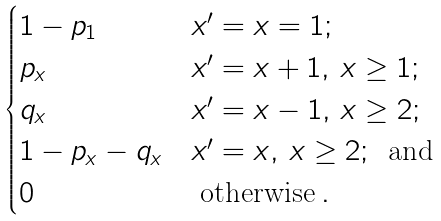Convert formula to latex. <formula><loc_0><loc_0><loc_500><loc_500>\begin{cases} 1 - p _ { 1 } & x ^ { \prime } = x = 1 ; \\ p _ { x } & x ^ { \prime } = x + 1 , \, x \geq 1 ; \\ q _ { x } & x ^ { \prime } = x - 1 , \, x \geq 2 ; \\ 1 - p _ { x } - q _ { x } & x ^ { \prime } = x , \, x \geq 2 ; \, \text { and} \\ 0 & \text { otherwise} \, . \end{cases}</formula> 